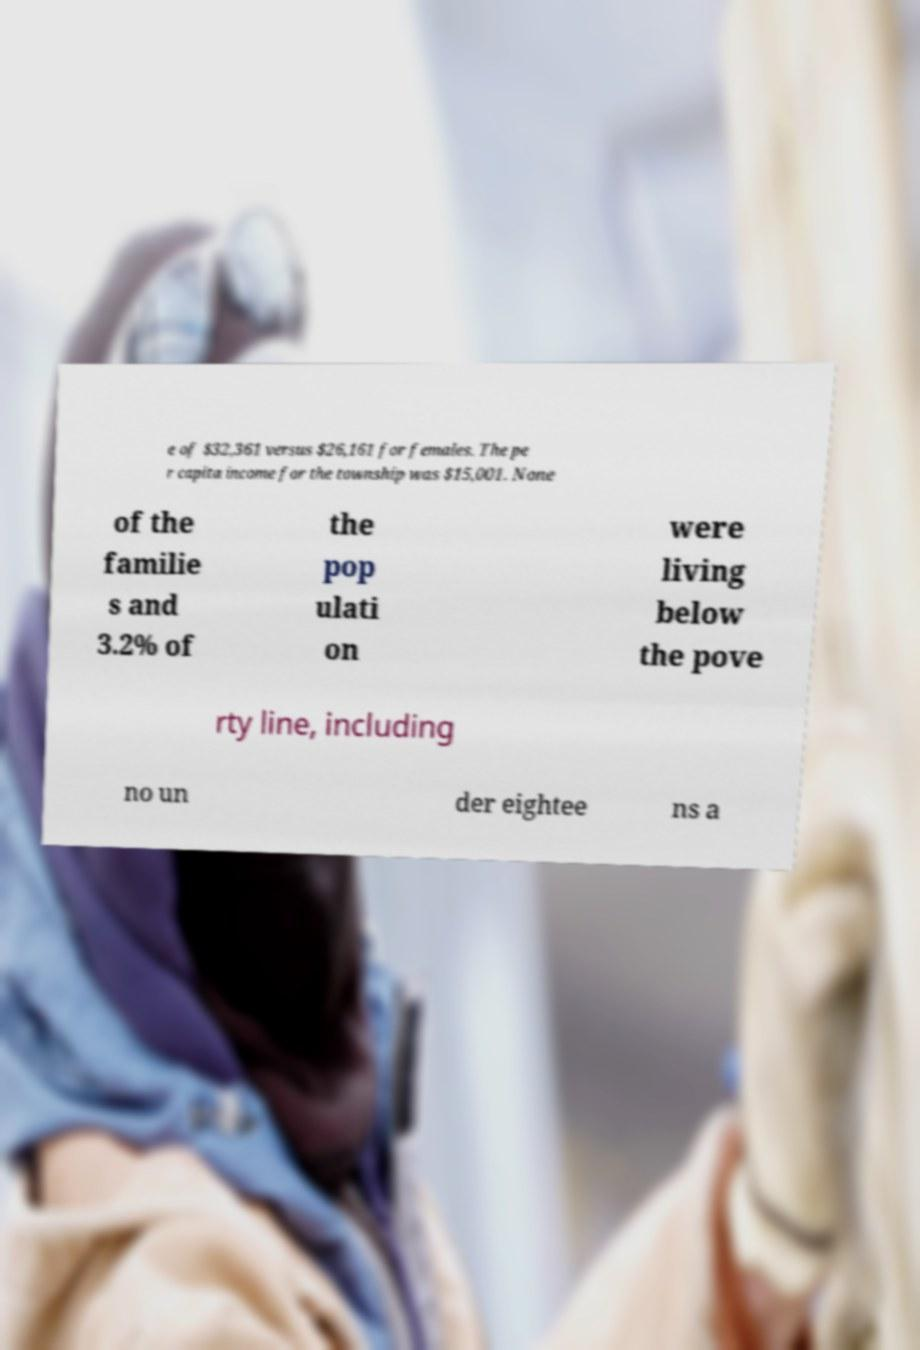There's text embedded in this image that I need extracted. Can you transcribe it verbatim? e of $32,361 versus $26,161 for females. The pe r capita income for the township was $15,001. None of the familie s and 3.2% of the pop ulati on were living below the pove rty line, including no un der eightee ns a 